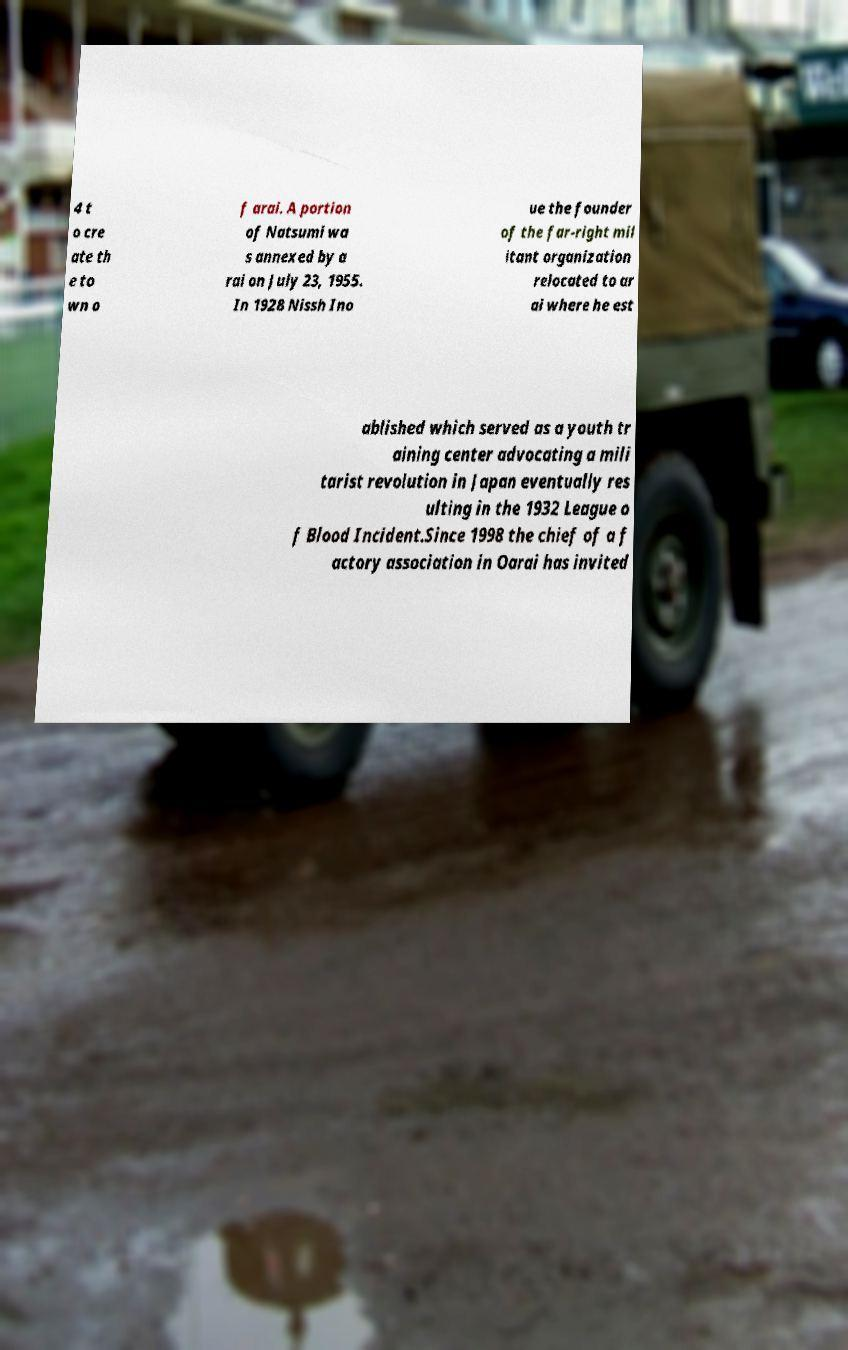For documentation purposes, I need the text within this image transcribed. Could you provide that? 4 t o cre ate th e to wn o f arai. A portion of Natsumi wa s annexed by a rai on July 23, 1955. In 1928 Nissh Ino ue the founder of the far-right mil itant organization relocated to ar ai where he est ablished which served as a youth tr aining center advocating a mili tarist revolution in Japan eventually res ulting in the 1932 League o f Blood Incident.Since 1998 the chief of a f actory association in Oarai has invited 